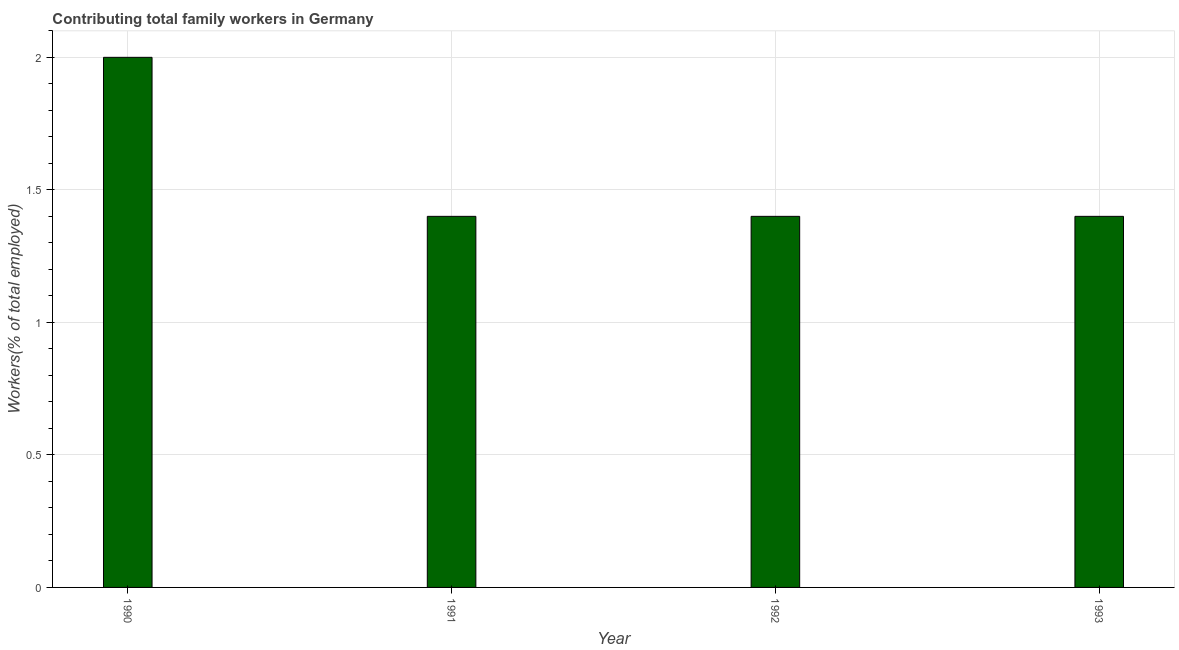Does the graph contain any zero values?
Offer a terse response. No. Does the graph contain grids?
Give a very brief answer. Yes. What is the title of the graph?
Provide a succinct answer. Contributing total family workers in Germany. What is the label or title of the X-axis?
Offer a very short reply. Year. What is the label or title of the Y-axis?
Offer a very short reply. Workers(% of total employed). What is the contributing family workers in 1993?
Give a very brief answer. 1.4. Across all years, what is the minimum contributing family workers?
Your answer should be very brief. 1.4. What is the sum of the contributing family workers?
Provide a short and direct response. 6.2. What is the difference between the contributing family workers in 1992 and 1993?
Ensure brevity in your answer.  0. What is the average contributing family workers per year?
Make the answer very short. 1.55. What is the median contributing family workers?
Your answer should be compact. 1.4. In how many years, is the contributing family workers greater than 0.9 %?
Your answer should be very brief. 4. Do a majority of the years between 1991 and 1993 (inclusive) have contributing family workers greater than 0.1 %?
Your answer should be compact. Yes. What is the ratio of the contributing family workers in 1992 to that in 1993?
Your answer should be compact. 1. What is the difference between the highest and the second highest contributing family workers?
Your answer should be compact. 0.6. What is the difference between the highest and the lowest contributing family workers?
Ensure brevity in your answer.  0.6. How many years are there in the graph?
Provide a short and direct response. 4. What is the difference between two consecutive major ticks on the Y-axis?
Keep it short and to the point. 0.5. Are the values on the major ticks of Y-axis written in scientific E-notation?
Provide a succinct answer. No. What is the Workers(% of total employed) of 1990?
Make the answer very short. 2. What is the Workers(% of total employed) in 1991?
Offer a terse response. 1.4. What is the Workers(% of total employed) of 1992?
Ensure brevity in your answer.  1.4. What is the Workers(% of total employed) in 1993?
Provide a short and direct response. 1.4. What is the difference between the Workers(% of total employed) in 1990 and 1993?
Keep it short and to the point. 0.6. What is the difference between the Workers(% of total employed) in 1991 and 1993?
Your answer should be very brief. 0. What is the difference between the Workers(% of total employed) in 1992 and 1993?
Your answer should be compact. 0. What is the ratio of the Workers(% of total employed) in 1990 to that in 1991?
Provide a short and direct response. 1.43. What is the ratio of the Workers(% of total employed) in 1990 to that in 1992?
Your response must be concise. 1.43. What is the ratio of the Workers(% of total employed) in 1990 to that in 1993?
Your response must be concise. 1.43. What is the ratio of the Workers(% of total employed) in 1992 to that in 1993?
Offer a very short reply. 1. 